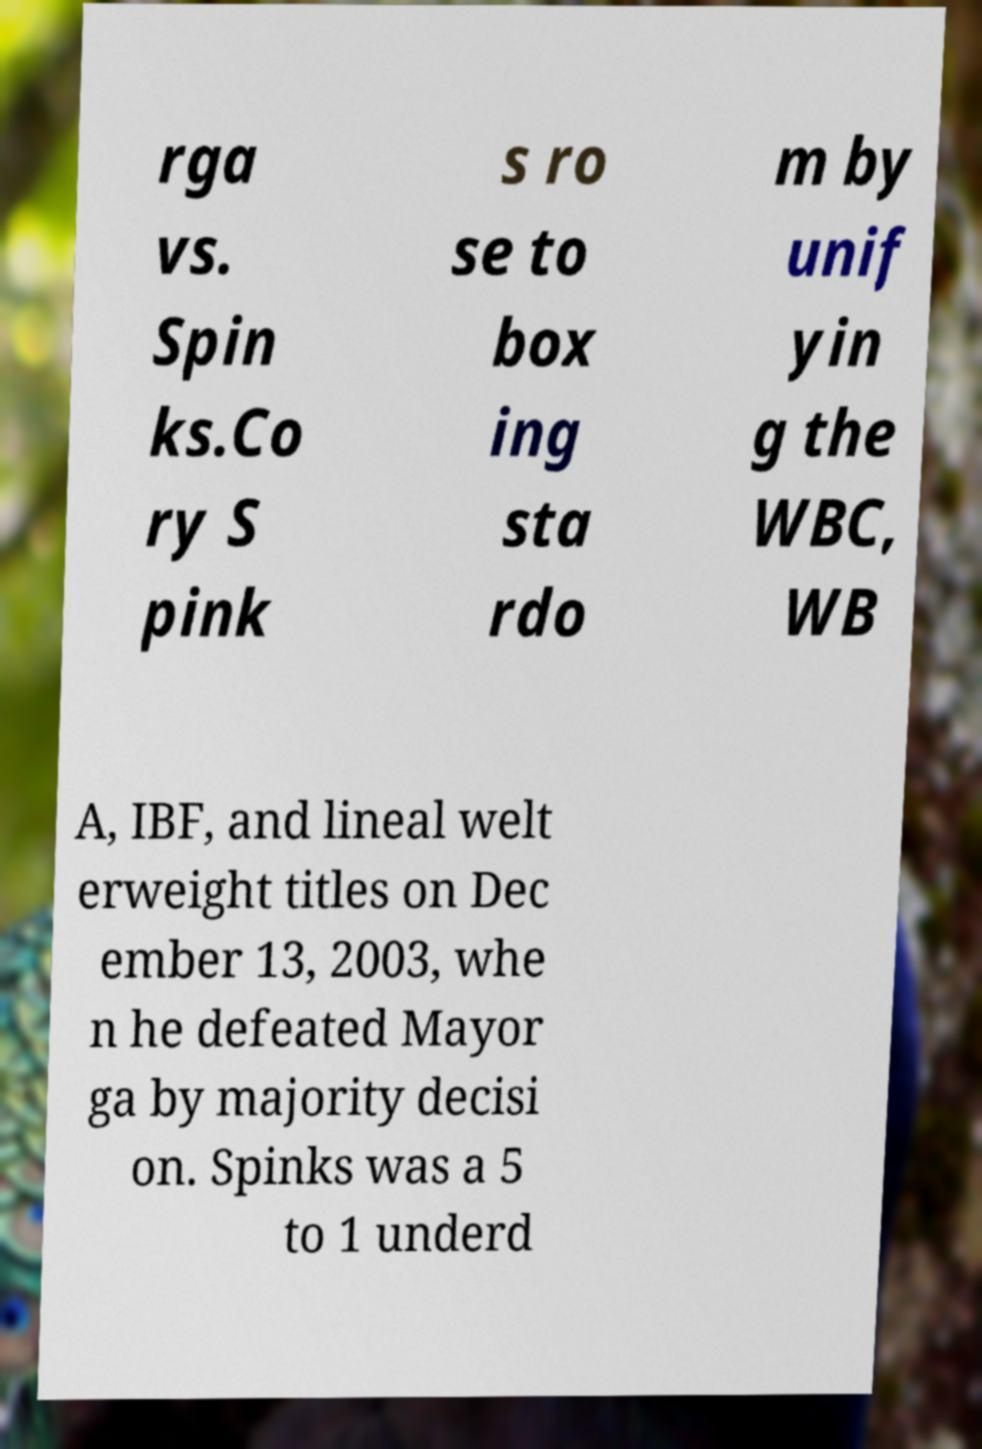For documentation purposes, I need the text within this image transcribed. Could you provide that? rga vs. Spin ks.Co ry S pink s ro se to box ing sta rdo m by unif yin g the WBC, WB A, IBF, and lineal welt erweight titles on Dec ember 13, 2003, whe n he defeated Mayor ga by majority decisi on. Spinks was a 5 to 1 underd 